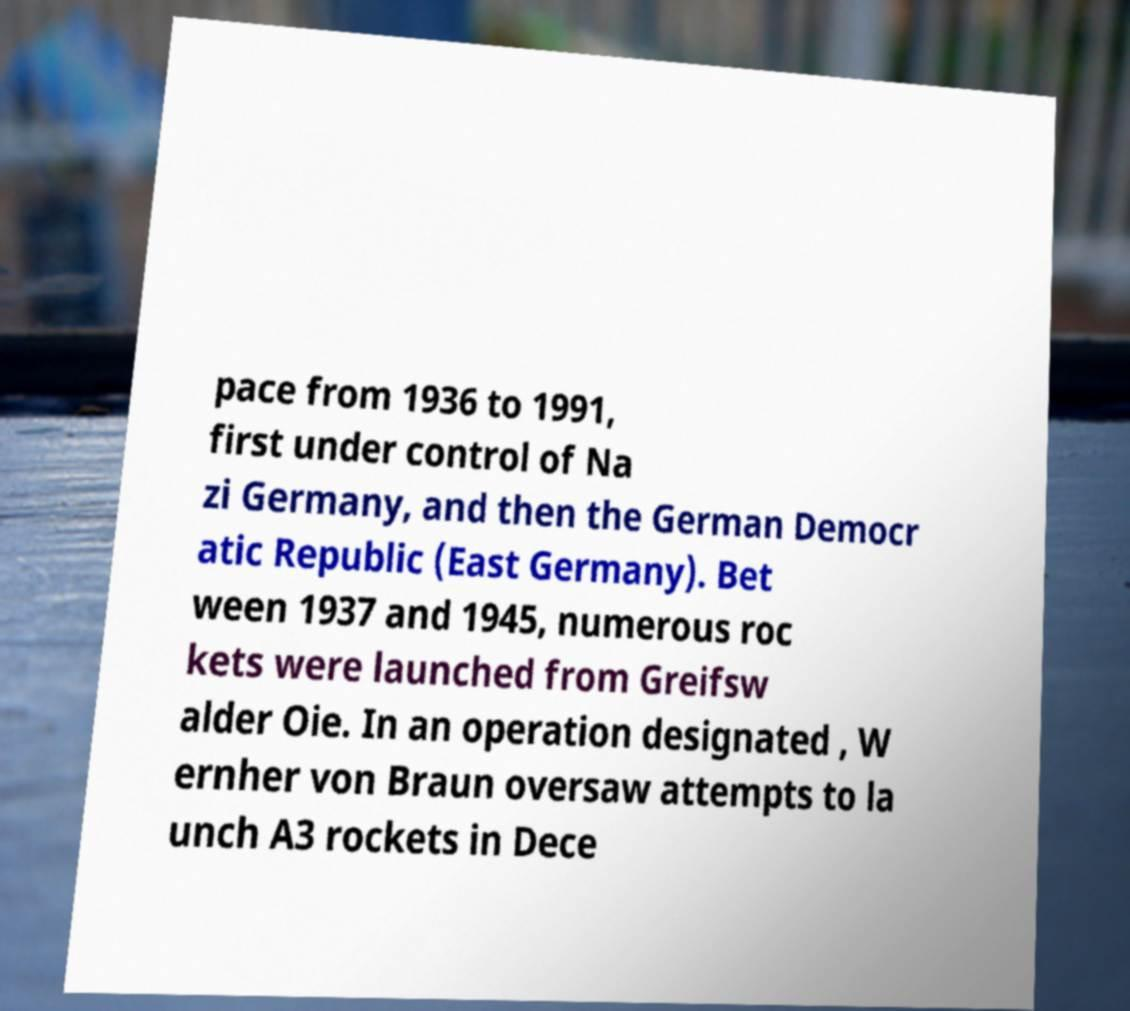What messages or text are displayed in this image? I need them in a readable, typed format. pace from 1936 to 1991, first under control of Na zi Germany, and then the German Democr atic Republic (East Germany). Bet ween 1937 and 1945, numerous roc kets were launched from Greifsw alder Oie. In an operation designated , W ernher von Braun oversaw attempts to la unch A3 rockets in Dece 